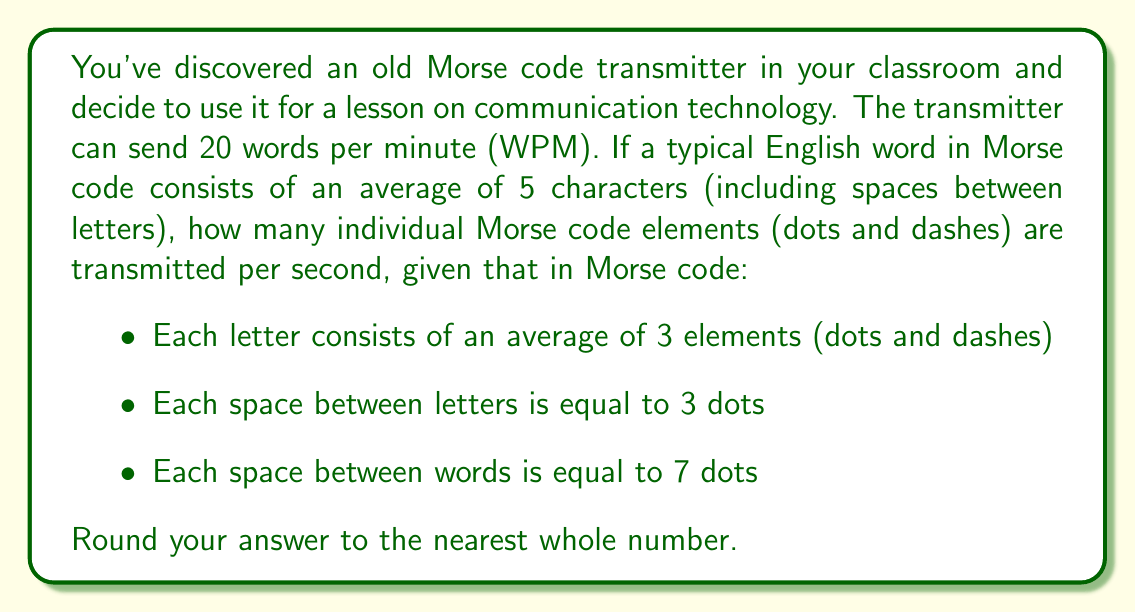Solve this math problem. Let's break this down step-by-step:

1. Calculate characters per minute:
   $20 \text{ words} \times 5 \text{ characters/word} = 100 \text{ characters/minute}$

2. Calculate elements per minute:
   - Letters: $100 \text{ characters} \times 3 \text{ elements/character} = 300 \text{ elements}$
   - Spaces between letters: $80 \text{ spaces} \times 3 \text{ dots} = 240 \text{ elements}$
   - Spaces between words: $19 \text{ spaces} \times 7 \text{ dots} = 133 \text{ elements}$
   Total: $300 + 240 + 133 = 673 \text{ elements/minute}$

3. Convert to elements per second:
   $$\frac{673 \text{ elements}}{60 \text{ seconds}} \approx 11.22 \text{ elements/second}$$

4. Round to the nearest whole number:
   $11.22 \approx 11 \text{ elements/second}$
Answer: 11 elements/second 